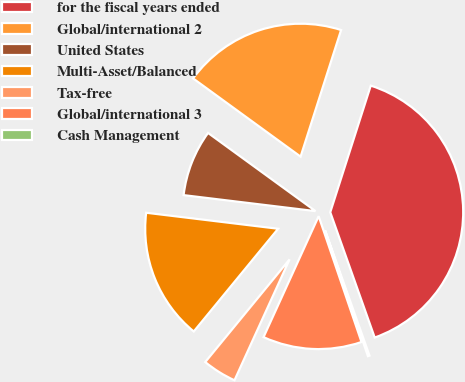Convert chart to OTSL. <chart><loc_0><loc_0><loc_500><loc_500><pie_chart><fcel>for the fiscal years ended<fcel>Global/international 2<fcel>United States<fcel>Multi-Asset/Balanced<fcel>Tax-free<fcel>Global/international 3<fcel>Cash Management<nl><fcel>39.65%<fcel>19.92%<fcel>8.09%<fcel>15.98%<fcel>4.14%<fcel>12.03%<fcel>0.2%<nl></chart> 